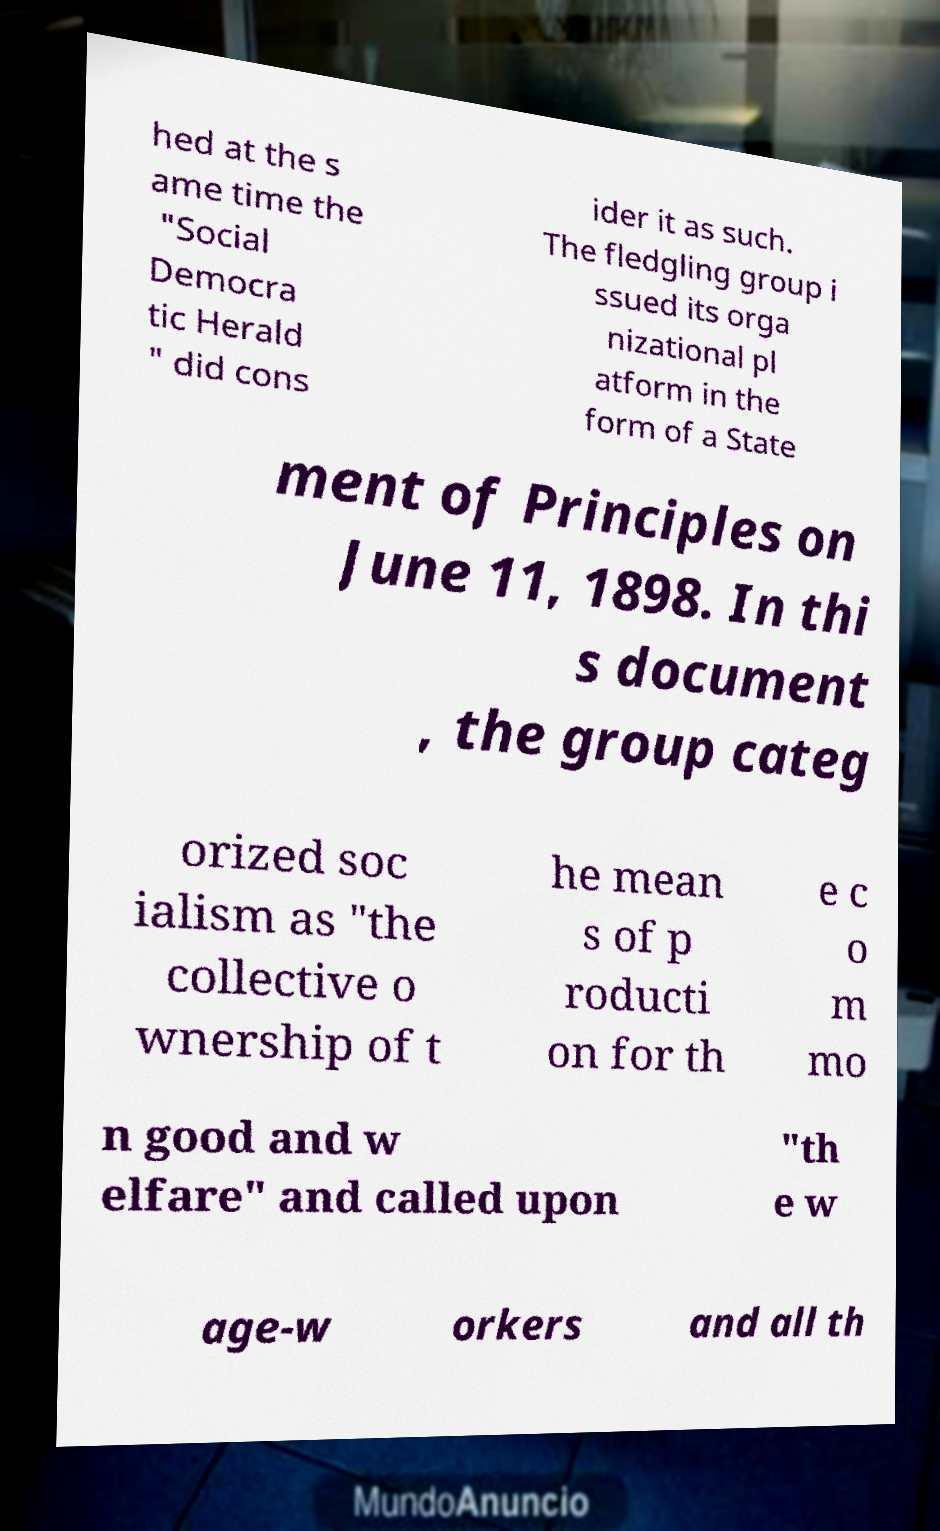Could you extract and type out the text from this image? hed at the s ame time the "Social Democra tic Herald " did cons ider it as such. The fledgling group i ssued its orga nizational pl atform in the form of a State ment of Principles on June 11, 1898. In thi s document , the group categ orized soc ialism as "the collective o wnership of t he mean s of p roducti on for th e c o m mo n good and w elfare" and called upon "th e w age-w orkers and all th 